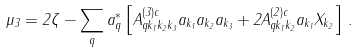<formula> <loc_0><loc_0><loc_500><loc_500>\mu _ { 3 } = 2 \zeta - \sum _ { q } a ^ { * } _ { q } \left [ A _ { q k _ { 1 } k _ { 2 } k _ { 3 } } ^ { ( 3 ) c } a _ { k _ { 1 } } a _ { k _ { 2 } } a _ { k _ { 3 } } + 2 A _ { q k _ { 1 } k _ { 2 } } ^ { ( 2 ) c } a _ { k _ { 1 } } X _ { k _ { 2 } } \right ] \, .</formula> 